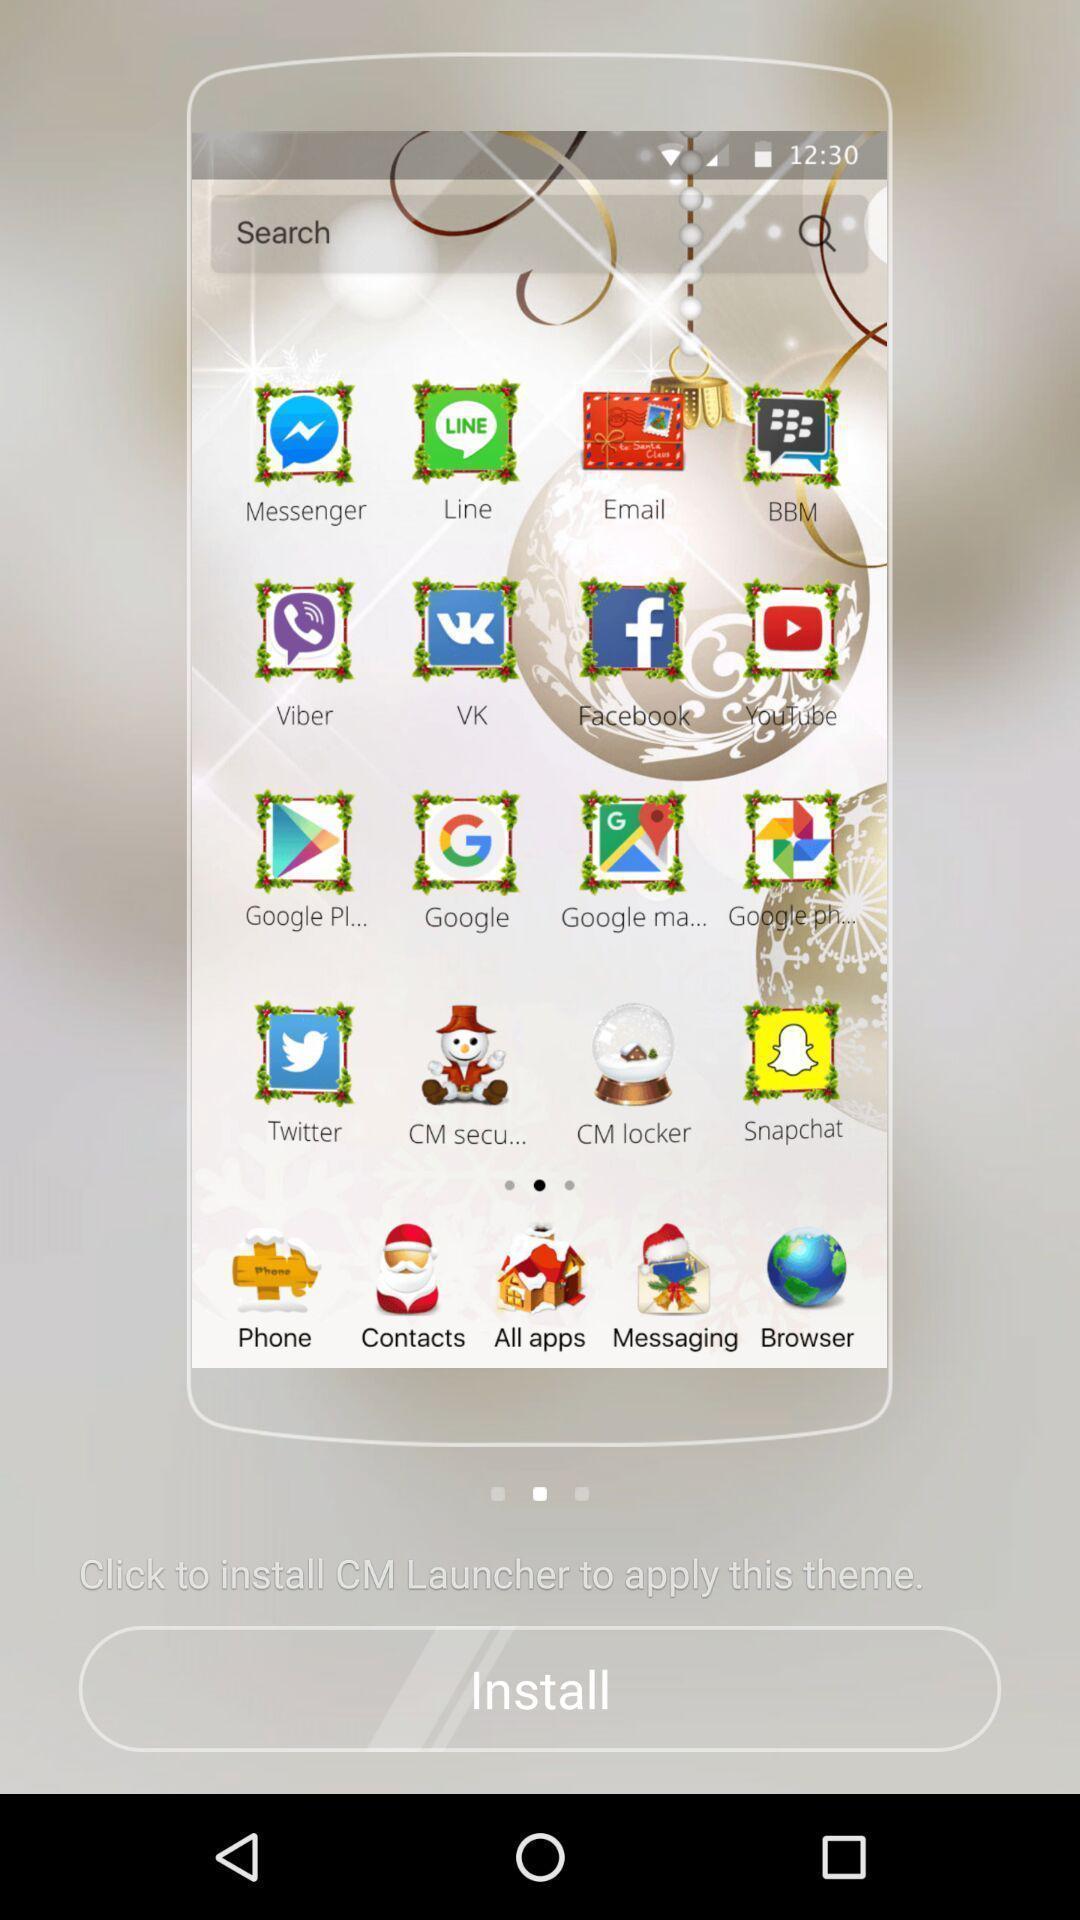Provide a description of this screenshot. Screen page displaying various options. 